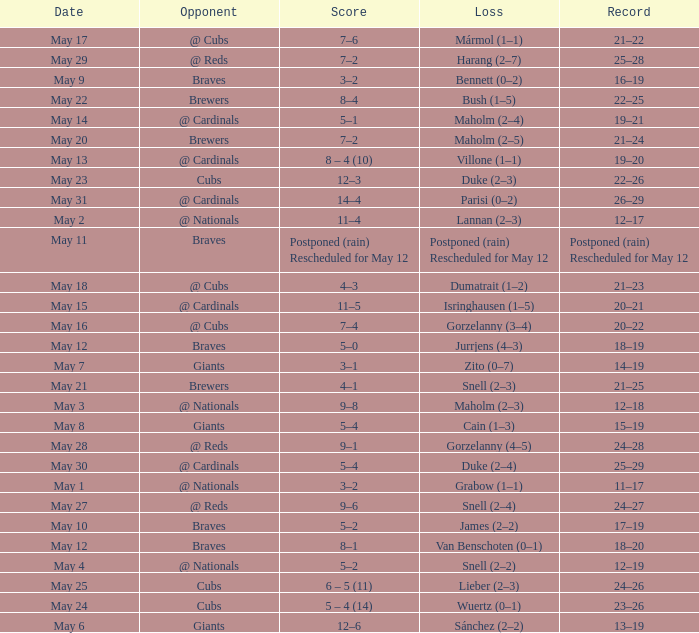Who was the opponent at the game with a score of 7–6? @ Cubs. 